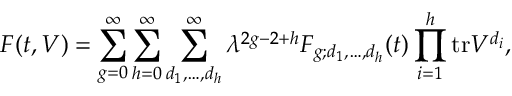<formula> <loc_0><loc_0><loc_500><loc_500>F ( t , V ) = \sum _ { g = 0 } ^ { \infty } \sum _ { h = 0 } ^ { \infty } \sum _ { d _ { 1 } , \dots , d _ { h } } ^ { \infty } \lambda ^ { 2 g - 2 + h } F _ { g ; d _ { 1 } , \dots , d _ { h } } ( t ) \prod _ { i = 1 } ^ { h } t r V ^ { d _ { i } } ,</formula> 